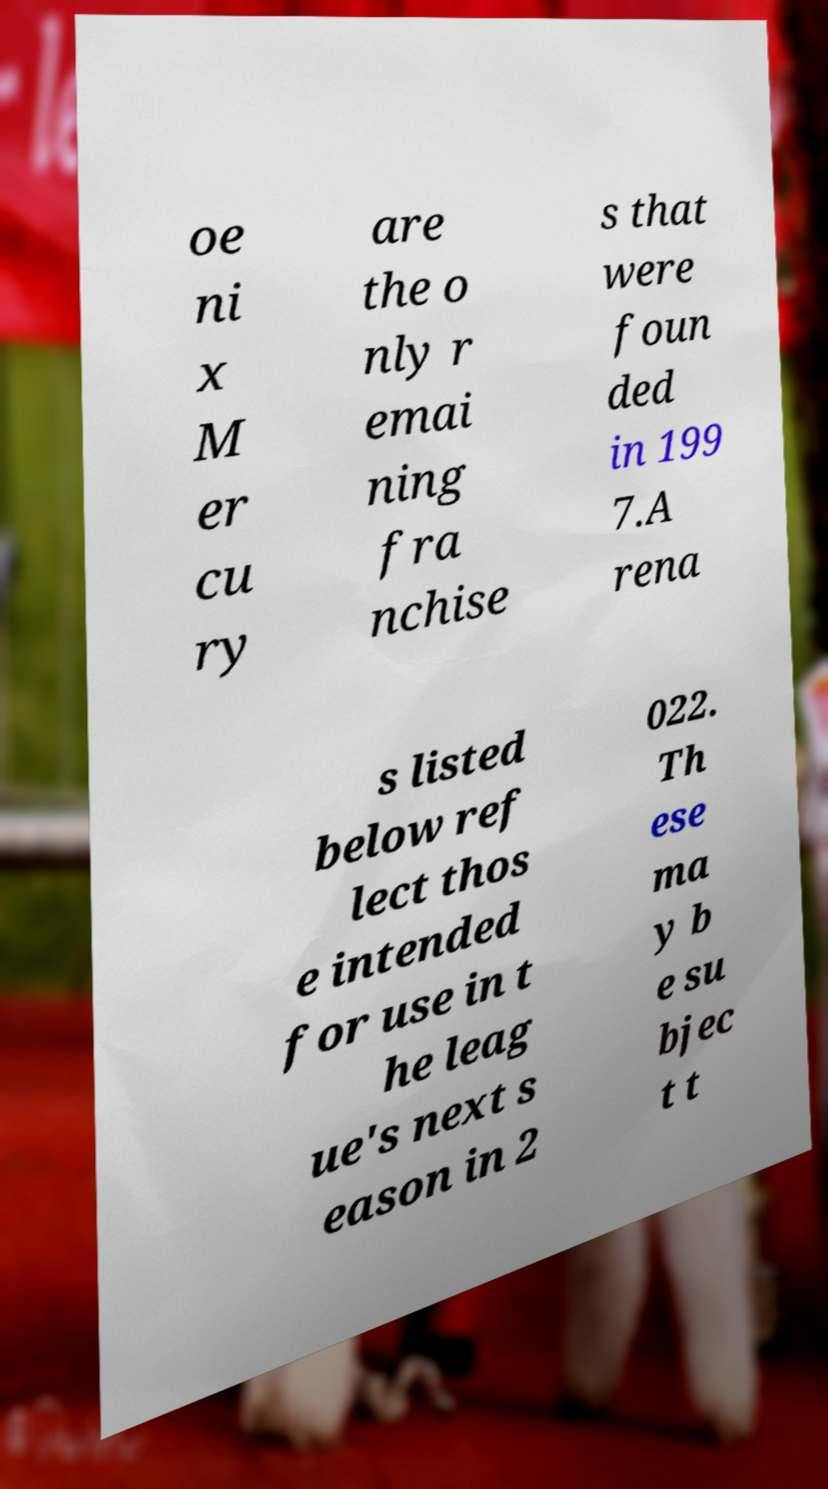Could you extract and type out the text from this image? oe ni x M er cu ry are the o nly r emai ning fra nchise s that were foun ded in 199 7.A rena s listed below ref lect thos e intended for use in t he leag ue's next s eason in 2 022. Th ese ma y b e su bjec t t 